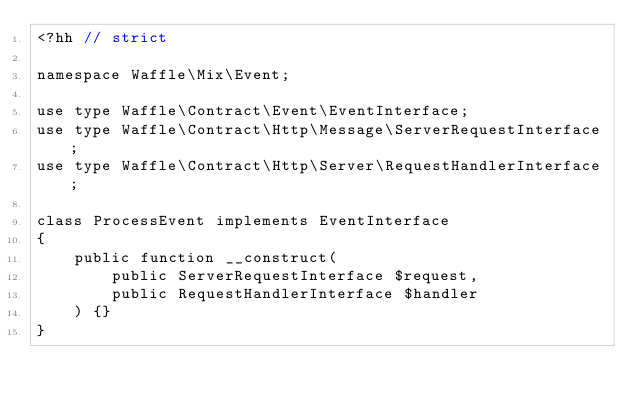Convert code to text. <code><loc_0><loc_0><loc_500><loc_500><_C++_><?hh // strict

namespace Waffle\Mix\Event;

use type Waffle\Contract\Event\EventInterface;
use type Waffle\Contract\Http\Message\ServerRequestInterface;
use type Waffle\Contract\Http\Server\RequestHandlerInterface;

class ProcessEvent implements EventInterface
{
    public function __construct(
        public ServerRequestInterface $request,
        public RequestHandlerInterface $handler
    ) {}
}
</code> 